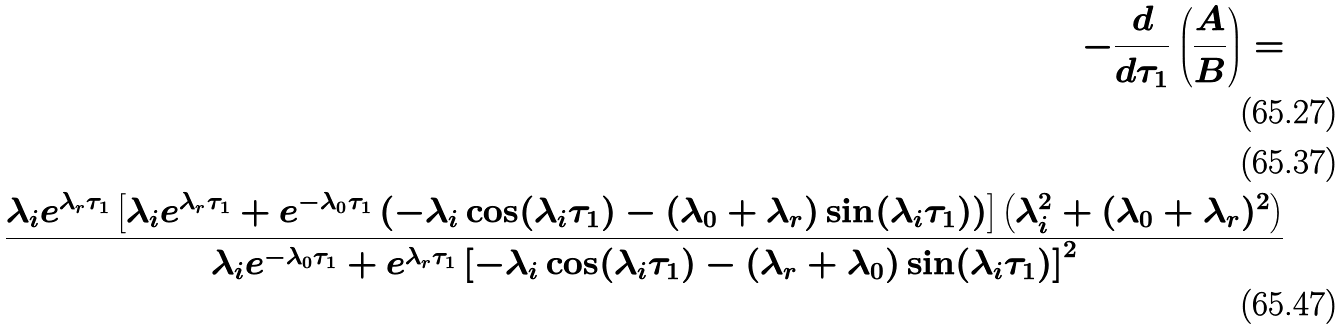<formula> <loc_0><loc_0><loc_500><loc_500>- \frac { d } { d \tau _ { 1 } } \left ( \frac { A } { B } \right ) = \\ \\ \frac { \lambda _ { i } e ^ { \lambda _ { r } \tau _ { 1 } } \left [ \lambda _ { i } e ^ { \lambda _ { r } \tau _ { 1 } } + e ^ { - \lambda _ { 0 } \tau _ { 1 } } \left ( - \lambda _ { i } \cos ( \lambda _ { i } \tau _ { 1 } ) - ( \lambda _ { 0 } + \lambda _ { r } ) \sin ( \lambda _ { i } \tau _ { 1 } ) \right ) \right ] \left ( \lambda _ { i } ^ { 2 } + ( \lambda _ { 0 } + \lambda _ { r } ) ^ { 2 } \right ) } { \lambda _ { i } e ^ { - \lambda _ { 0 } \tau _ { 1 } } + e ^ { \lambda _ { r } \tau _ { 1 } } \left [ - \lambda _ { i } \cos ( \lambda _ { i } \tau _ { 1 } ) - ( \lambda _ { r } + \lambda _ { 0 } ) \sin ( \lambda _ { i } \tau _ { 1 } ) \right ] ^ { 2 } }</formula> 